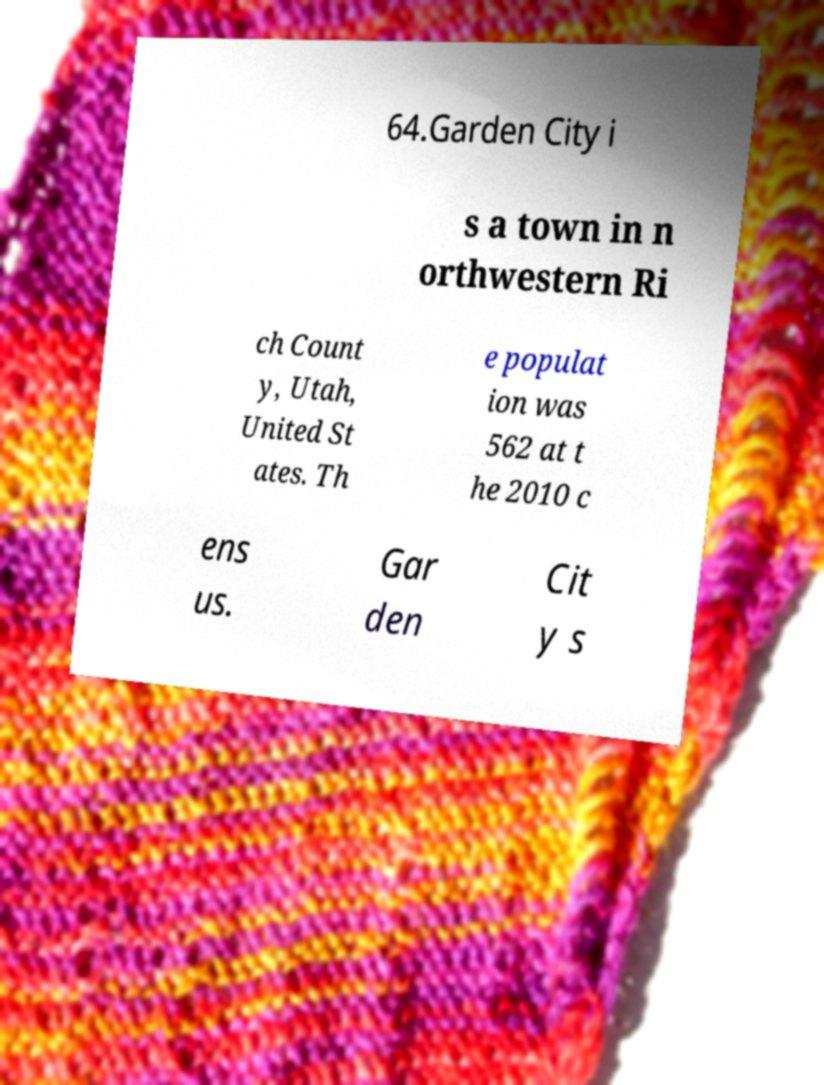Can you read and provide the text displayed in the image?This photo seems to have some interesting text. Can you extract and type it out for me? 64.Garden City i s a town in n orthwestern Ri ch Count y, Utah, United St ates. Th e populat ion was 562 at t he 2010 c ens us. Gar den Cit y s 